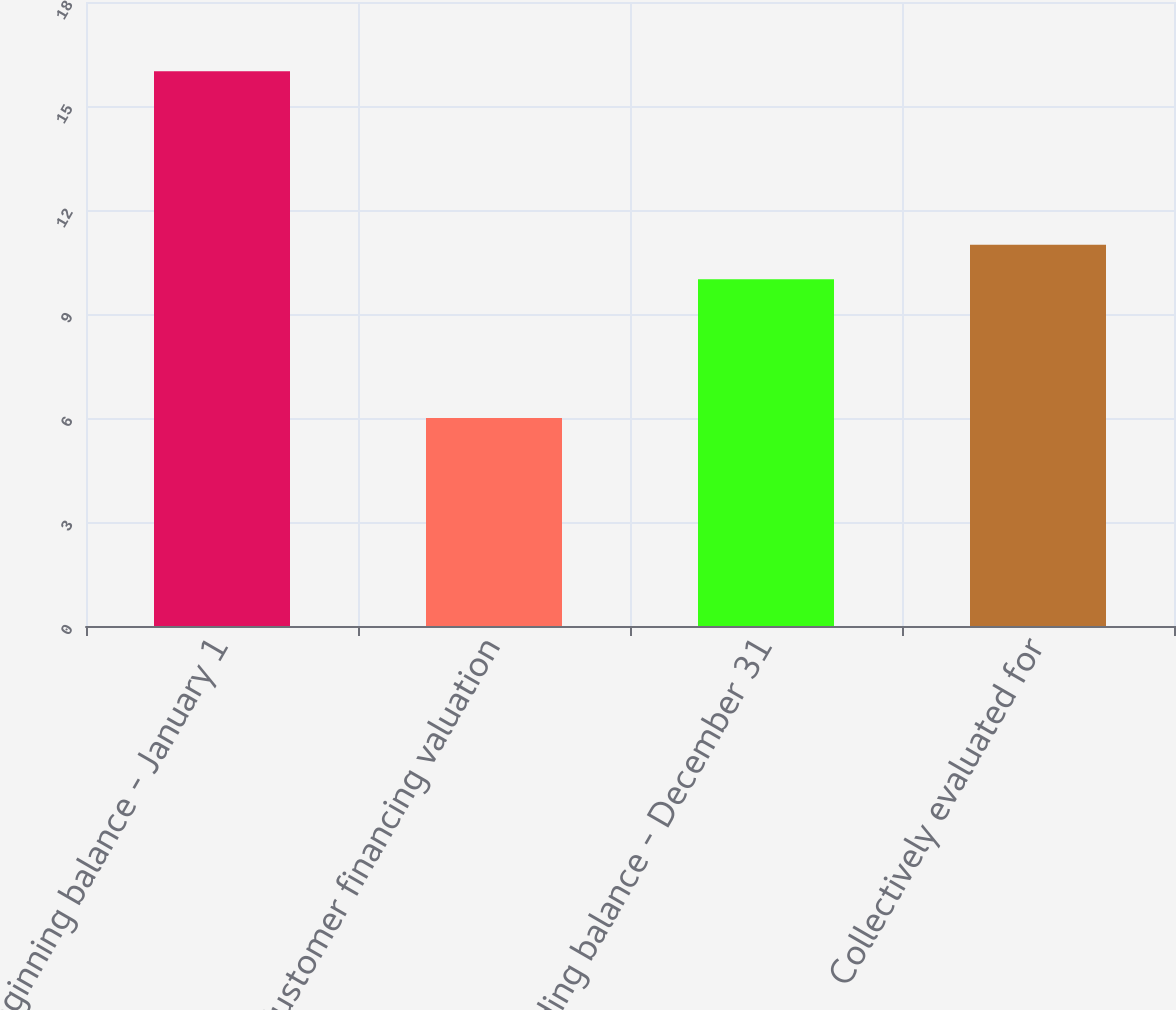Convert chart. <chart><loc_0><loc_0><loc_500><loc_500><bar_chart><fcel>Beginning balance - January 1<fcel>Customer financing valuation<fcel>Ending balance - December 31<fcel>Collectively evaluated for<nl><fcel>16<fcel>6<fcel>10<fcel>11<nl></chart> 